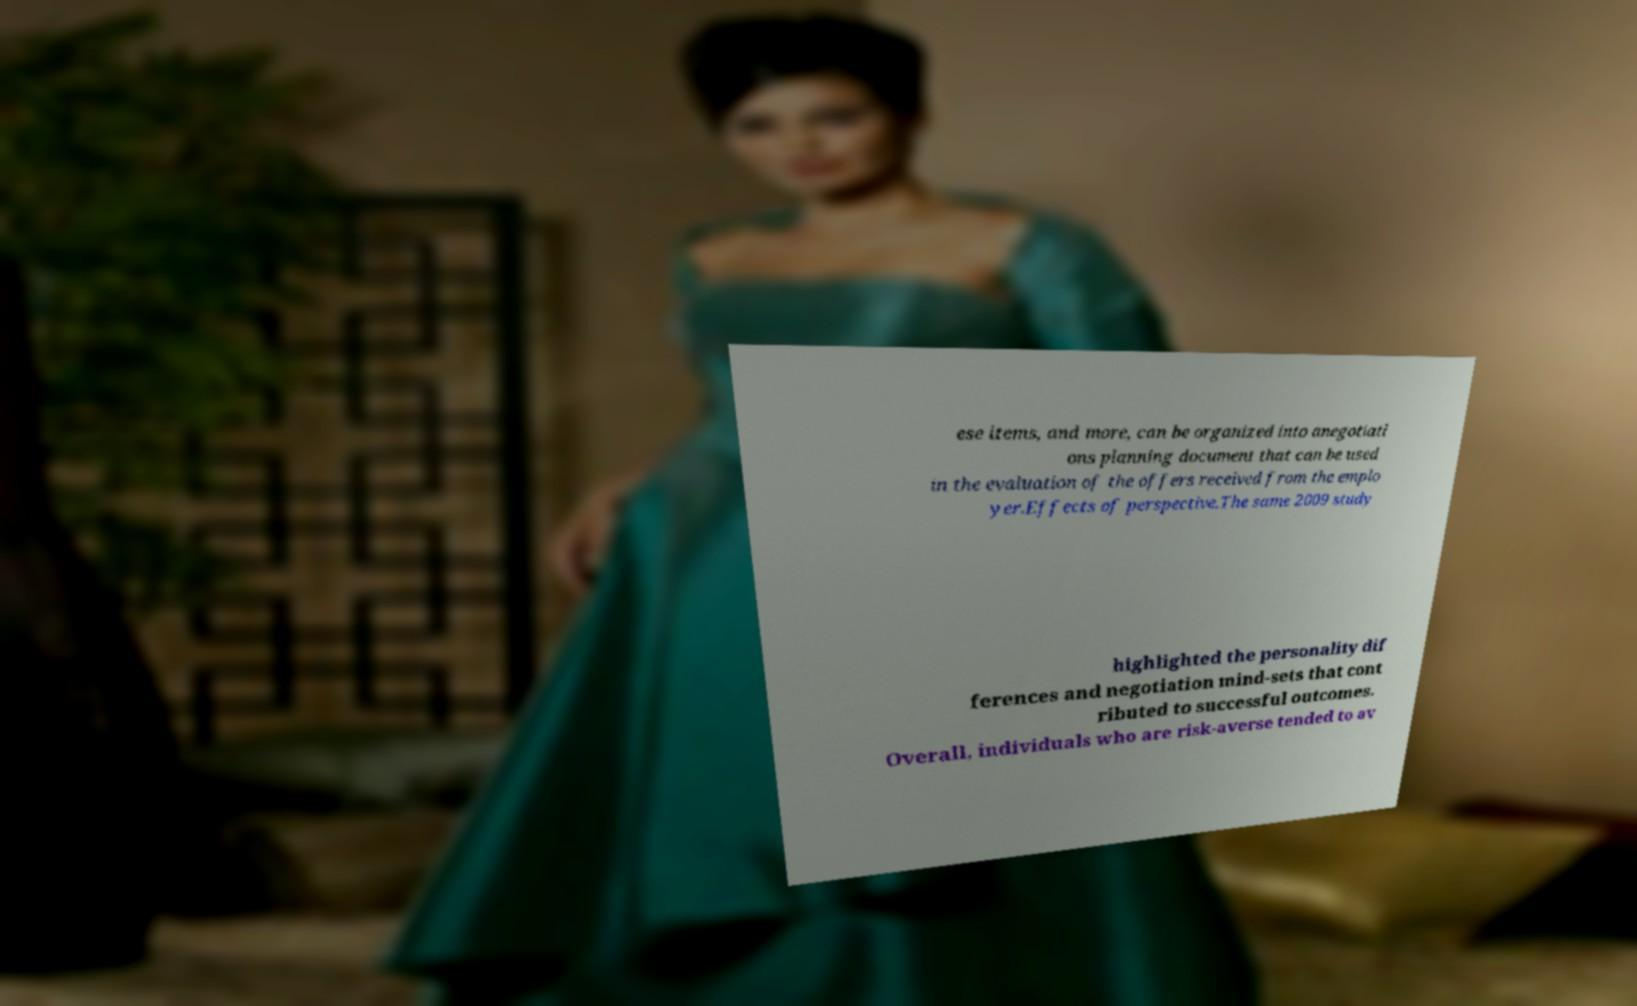Can you accurately transcribe the text from the provided image for me? ese items, and more, can be organized into anegotiati ons planning document that can be used in the evaluation of the offers received from the emplo yer.Effects of perspective.The same 2009 study highlighted the personality dif ferences and negotiation mind-sets that cont ributed to successful outcomes. Overall, individuals who are risk-averse tended to av 